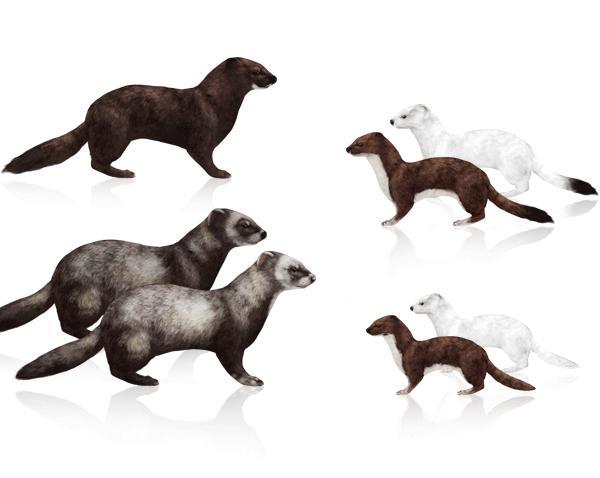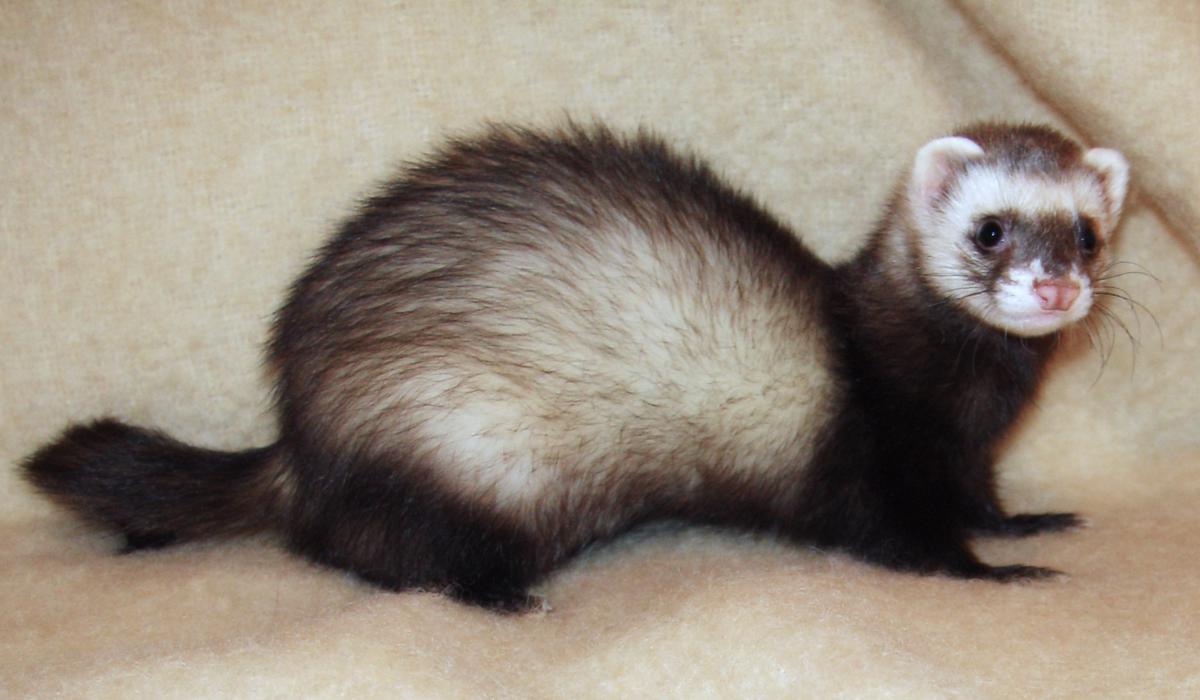The first image is the image on the left, the second image is the image on the right. Examine the images to the left and right. Is the description "At least 1 of the animals is standing outdoors." accurate? Answer yes or no. No. 